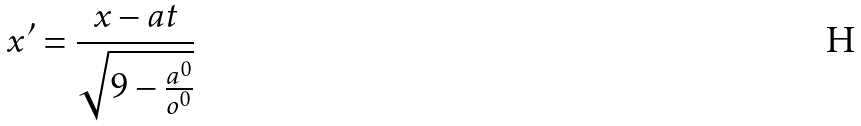Convert formula to latex. <formula><loc_0><loc_0><loc_500><loc_500>x ^ { \prime } = \frac { x - a t } { \sqrt { 9 - \frac { a ^ { 0 } } { o ^ { 0 } } } }</formula> 